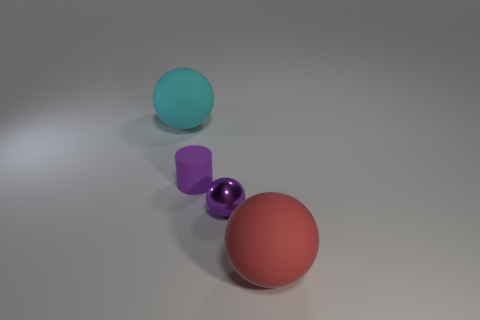Subtract all small purple spheres. How many spheres are left? 2 Add 1 red balls. How many objects exist? 5 Subtract all purple spheres. How many spheres are left? 2 Subtract all cylinders. How many objects are left? 3 Subtract all green balls. Subtract all purple cylinders. How many balls are left? 3 Subtract all red cylinders. How many red spheres are left? 1 Subtract all tiny cyan things. Subtract all small purple rubber things. How many objects are left? 3 Add 3 cylinders. How many cylinders are left? 4 Add 1 big gray objects. How many big gray objects exist? 1 Subtract 0 red cylinders. How many objects are left? 4 